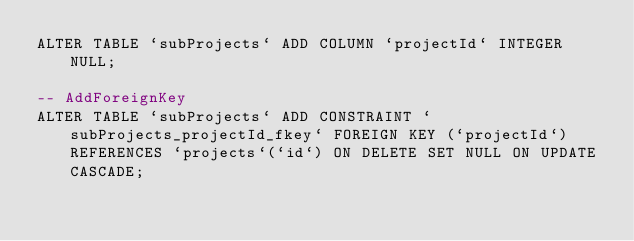<code> <loc_0><loc_0><loc_500><loc_500><_SQL_>ALTER TABLE `subProjects` ADD COLUMN `projectId` INTEGER NULL;

-- AddForeignKey
ALTER TABLE `subProjects` ADD CONSTRAINT `subProjects_projectId_fkey` FOREIGN KEY (`projectId`) REFERENCES `projects`(`id`) ON DELETE SET NULL ON UPDATE CASCADE;
</code> 